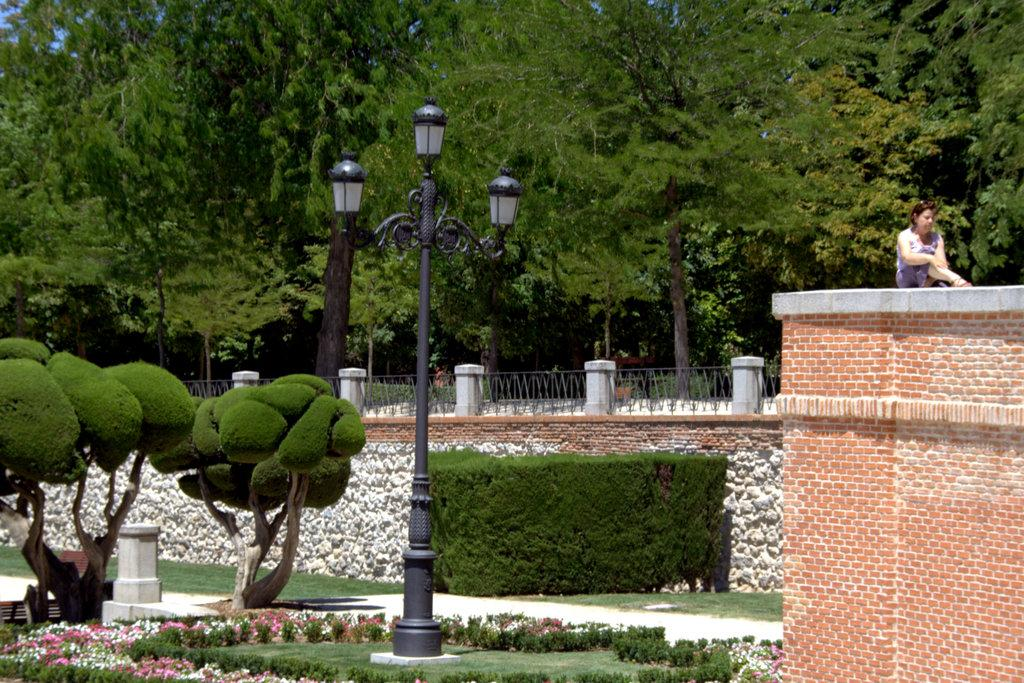What type of vegetation can be seen in the image? There are trees, plants, grass, and flowers in the image. What type of structures are present in the image? There is a fence, a pole, a wall, and a building in the image. What is the person in the image doing? The person is sitting on a building in the image. What type of lighting is present in the image? There are lights in the image. How many icicles are hanging from the trees in the image? There are no icicles present in the image, as it features trees, plants, grass, and flowers in a natural setting. What type of underwear is the person sitting on the building wearing? There is no information about the person's clothing in the image, and therefore it cannot be determined. 